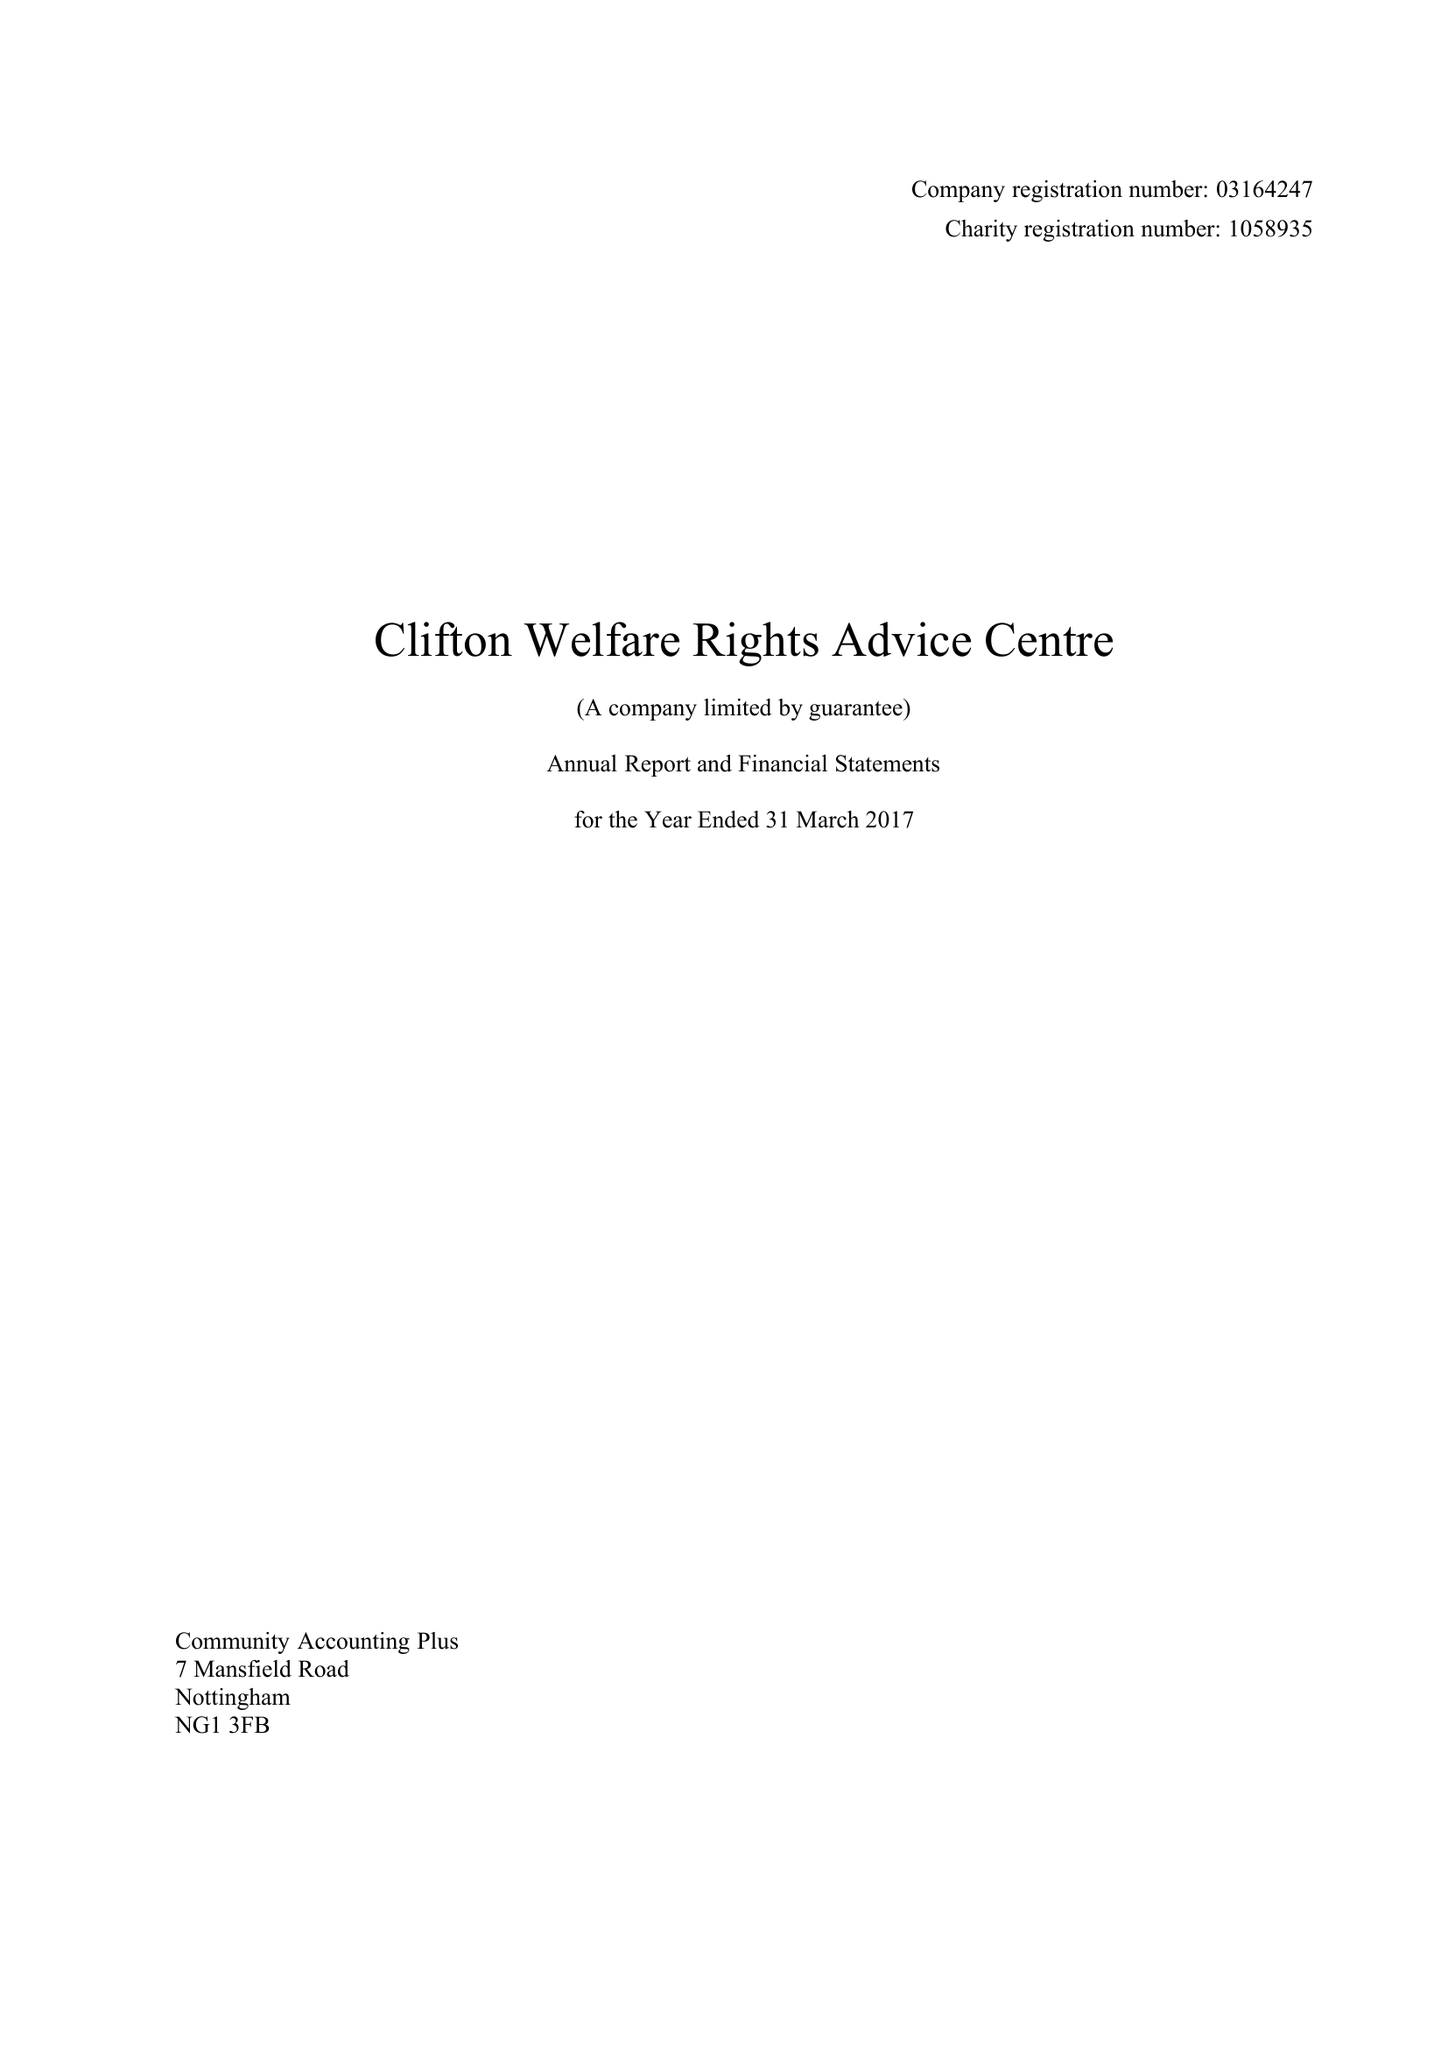What is the value for the address__postcode?
Answer the question using a single word or phrase. NG11 8EW 